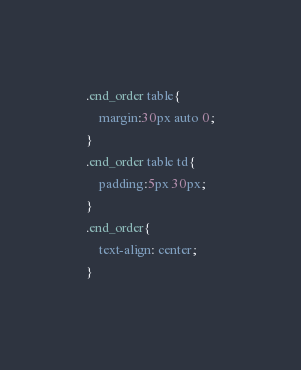<code> <loc_0><loc_0><loc_500><loc_500><_CSS_>.end_order table{
    margin:30px auto 0;
}
.end_order table td{
    padding:5px 30px;
}
.end_order{
    text-align: center;
}
</code> 